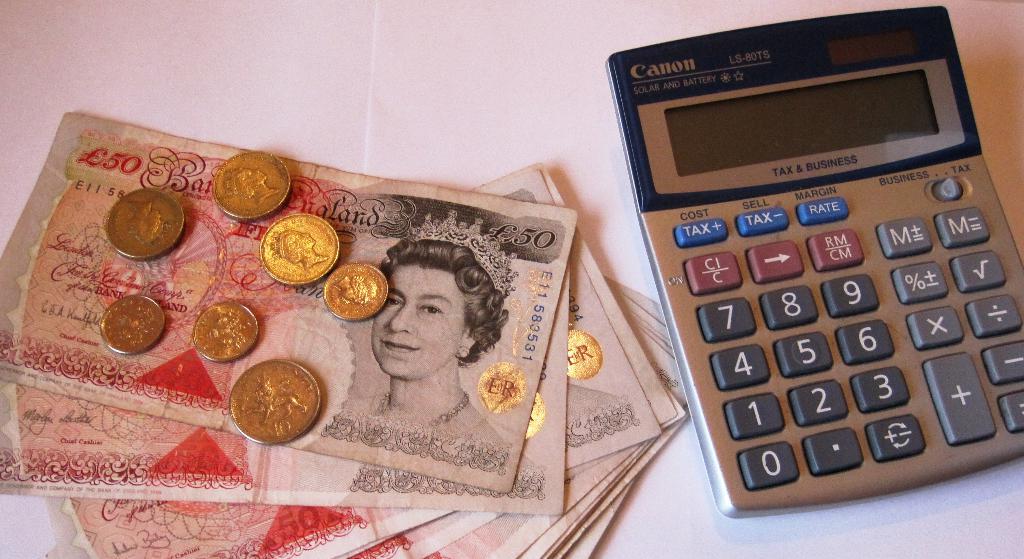Is the calculator switched to business or tax mode?
Your answer should be compact. Tax. What brand of calculator is pictured?
Make the answer very short. Canon. 